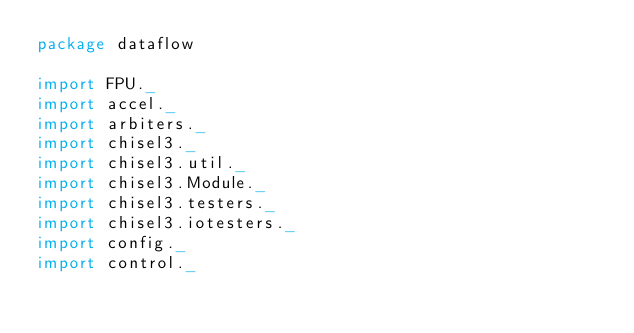Convert code to text. <code><loc_0><loc_0><loc_500><loc_500><_Scala_>package dataflow

import FPU._
import accel._
import arbiters._
import chisel3._
import chisel3.util._
import chisel3.Module._
import chisel3.testers._
import chisel3.iotesters._
import config._
import control._</code> 